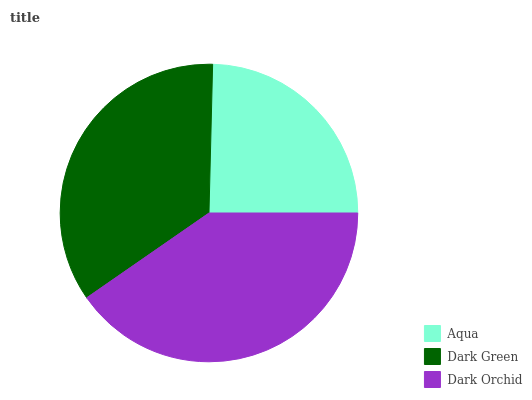Is Aqua the minimum?
Answer yes or no. Yes. Is Dark Orchid the maximum?
Answer yes or no. Yes. Is Dark Green the minimum?
Answer yes or no. No. Is Dark Green the maximum?
Answer yes or no. No. Is Dark Green greater than Aqua?
Answer yes or no. Yes. Is Aqua less than Dark Green?
Answer yes or no. Yes. Is Aqua greater than Dark Green?
Answer yes or no. No. Is Dark Green less than Aqua?
Answer yes or no. No. Is Dark Green the high median?
Answer yes or no. Yes. Is Dark Green the low median?
Answer yes or no. Yes. Is Aqua the high median?
Answer yes or no. No. Is Dark Orchid the low median?
Answer yes or no. No. 